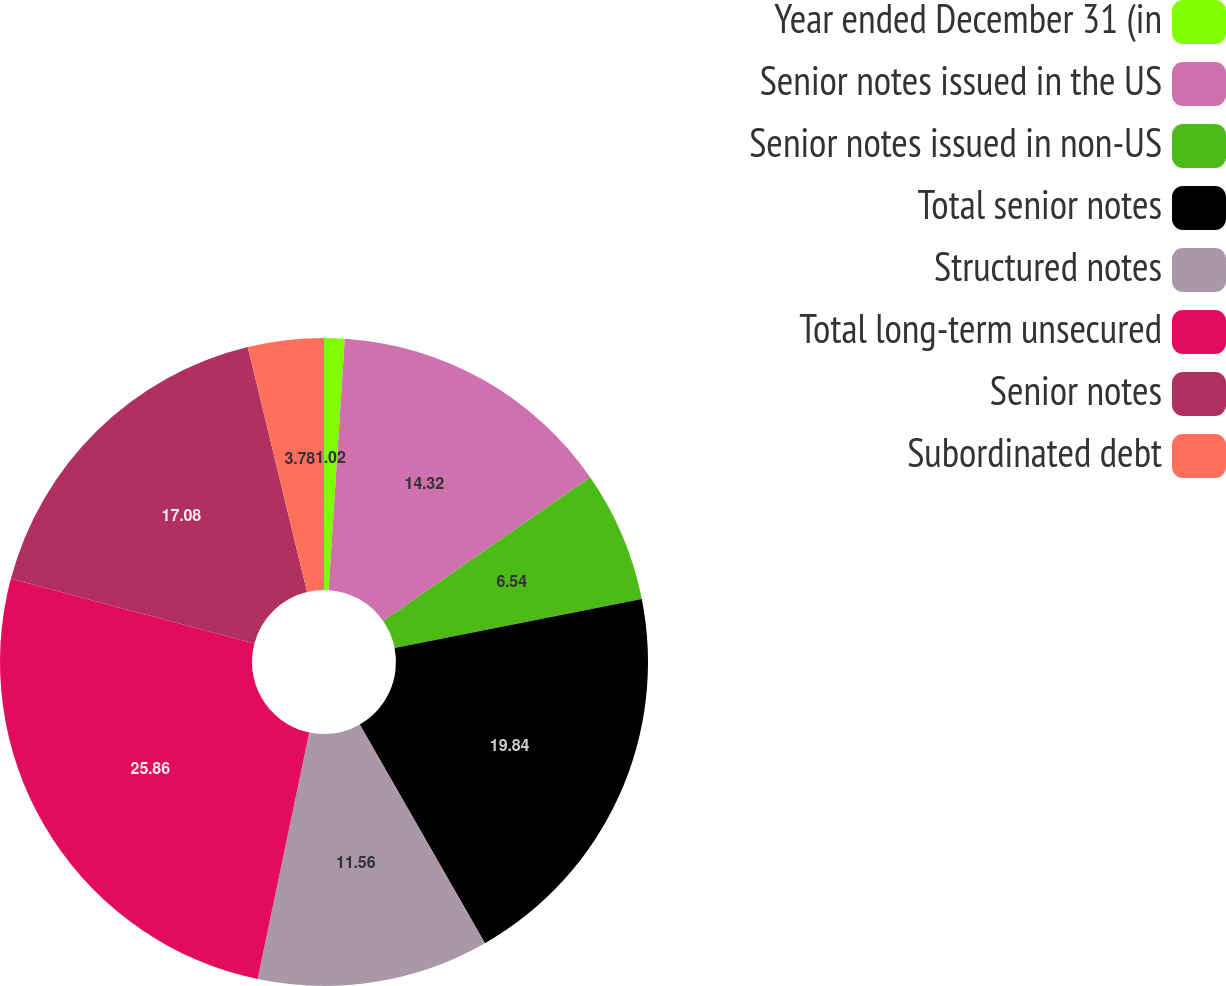<chart> <loc_0><loc_0><loc_500><loc_500><pie_chart><fcel>Year ended December 31 (in<fcel>Senior notes issued in the US<fcel>Senior notes issued in non-US<fcel>Total senior notes<fcel>Structured notes<fcel>Total long-term unsecured<fcel>Senior notes<fcel>Subordinated debt<nl><fcel>1.02%<fcel>14.32%<fcel>6.54%<fcel>19.84%<fcel>11.56%<fcel>25.85%<fcel>17.08%<fcel>3.78%<nl></chart> 